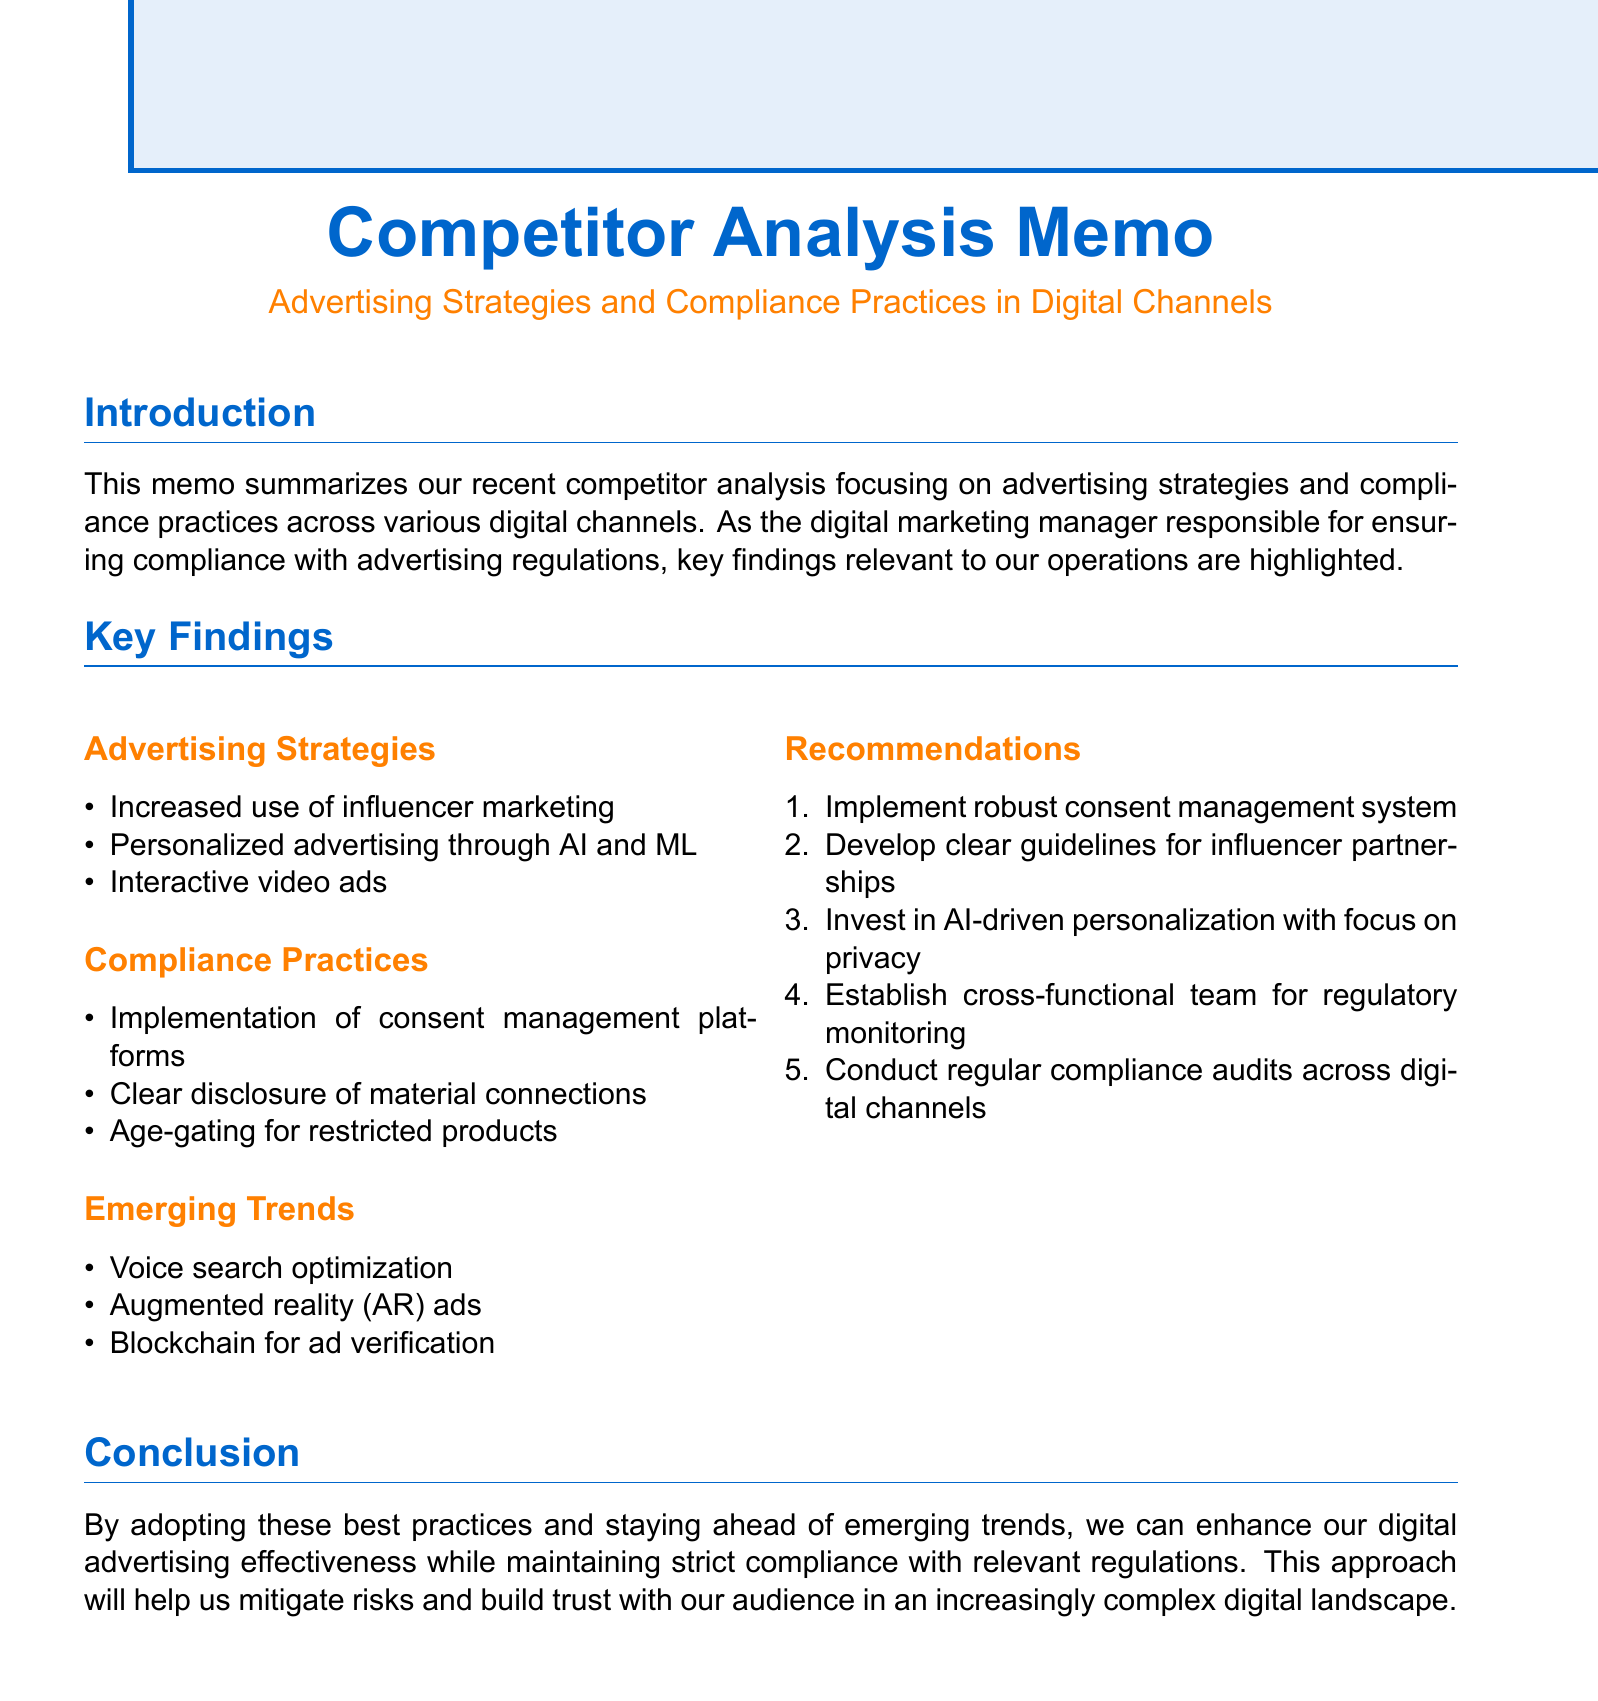What is the title of the memo? The title of the memo is clearly stated at the beginning as "Competitor Analysis: Advertising Strategies and Compliance Practices in Digital Channels."
Answer: Competitor Analysis: Advertising Strategies and Compliance Practices in Digital Channels How many competitors were analyzed? The memo lists five competitors that were analyzed for the report.
Answer: 5 Which company is mentioned for its use of micro-influencers? The document provides an example of Nike collaborating with micro-influencers for localized campaigns under advertising strategies.
Answer: Nike What compliance practice did Lululemon implement? The memo states that Lululemon implemented a cookie consent banner and preference center as part of their compliance practices.
Answer: Cookie consent banner and preference center What is one of the emerging trends mentioned? The document outlines emerging trends, one of which is voice search optimization.
Answer: Voice search optimization What is a recommendation given in the memo? The memo provides recommendations including implementing a robust consent management system to ensure compliance.
Answer: Implement robust consent management system Which digital channel is assessed that includes platforms like YouTube? The memo categorizes video platforms, which include platforms like YouTube, as one of the digital channels assessed.
Answer: Video platforms What are the compliance considerations mentioned with personalized advertising? The memo advises adherence to GDPR and CCPA regulations for data collection and usage in the context of personalized advertising.
Answer: GDPR and CCPA regulations 